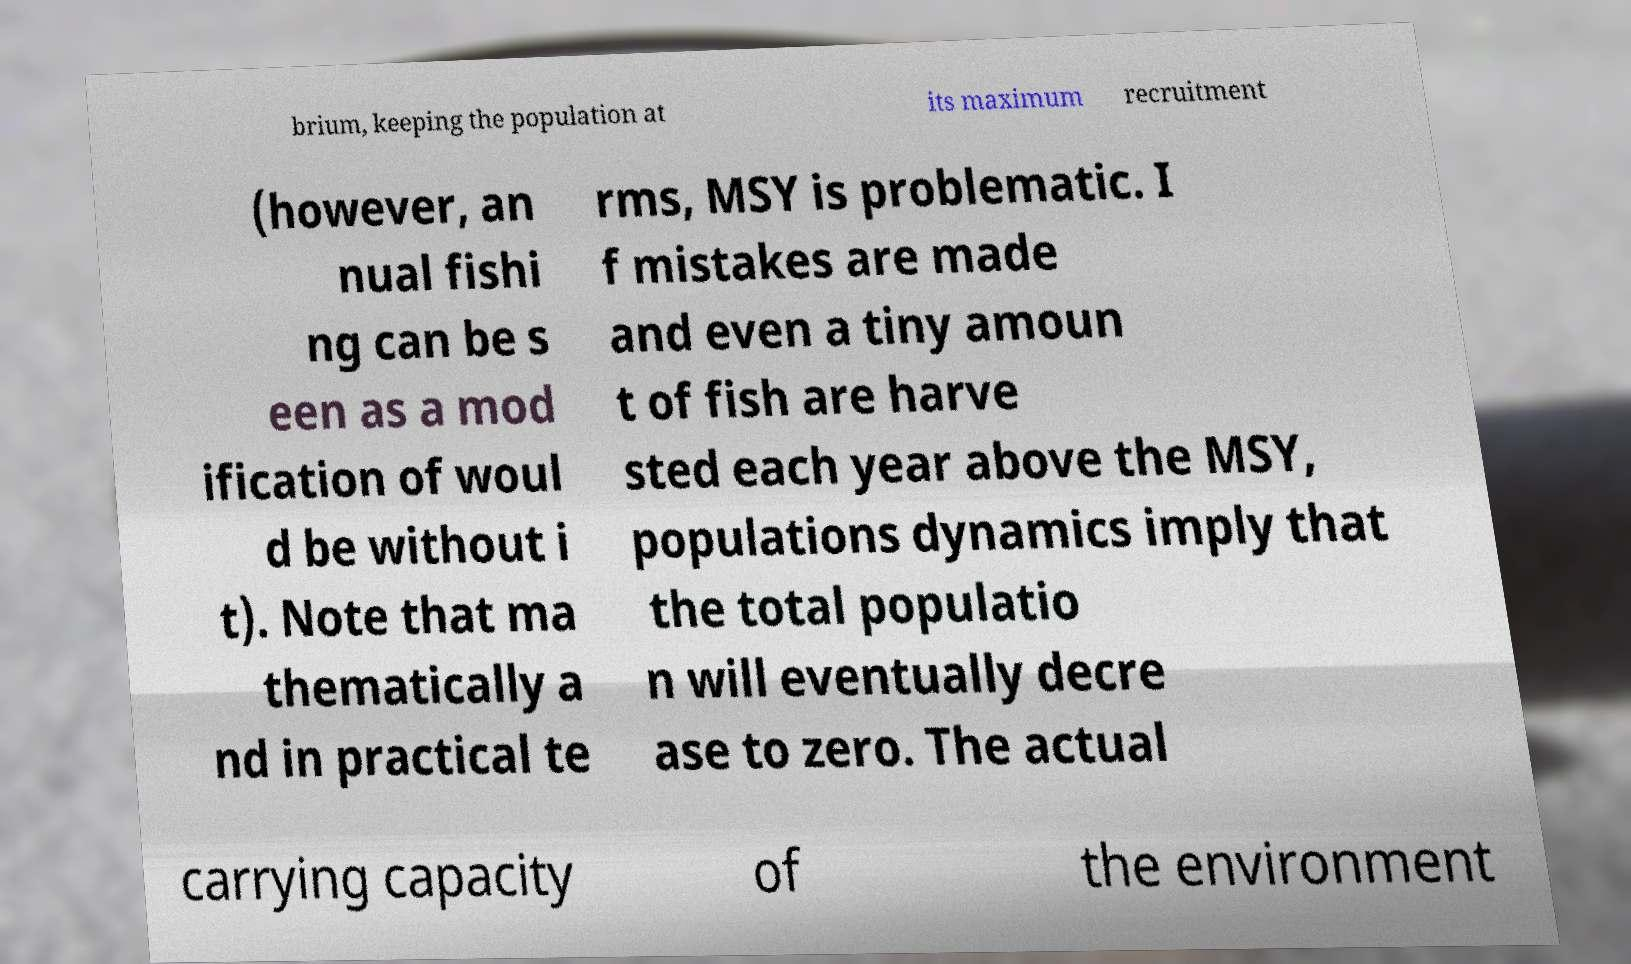Could you extract and type out the text from this image? brium, keeping the population at its maximum recruitment (however, an nual fishi ng can be s een as a mod ification of woul d be without i t). Note that ma thematically a nd in practical te rms, MSY is problematic. I f mistakes are made and even a tiny amoun t of fish are harve sted each year above the MSY, populations dynamics imply that the total populatio n will eventually decre ase to zero. The actual carrying capacity of the environment 